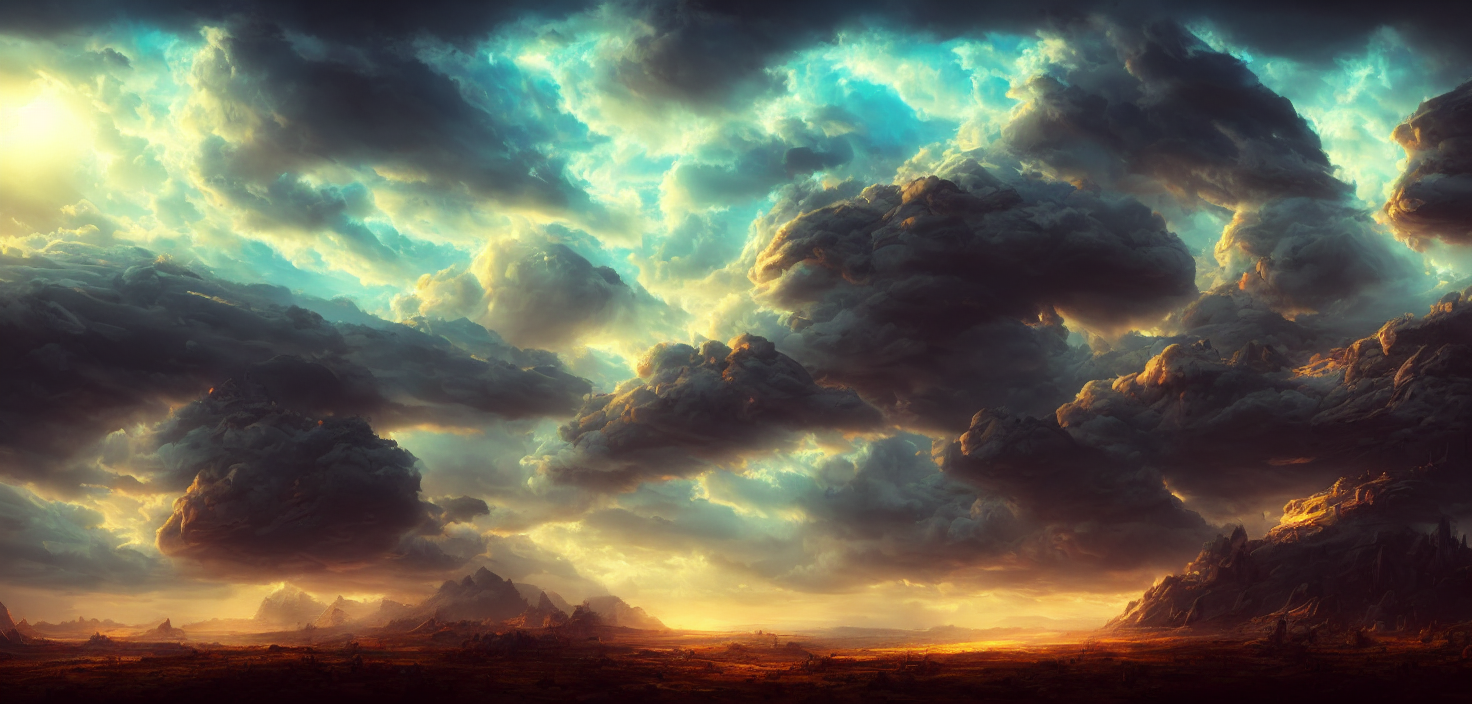What time of day does this image likely represent, and why? This image likely represents either sunrise or sunset, as indicated by the warm golden hues near the horizon and the low angle of the light casting long shadows. Such lighting conditions typically occur when the sun is near the horizon at the beginning or end of the day. 